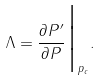Convert formula to latex. <formula><loc_0><loc_0><loc_500><loc_500>\Lambda = \frac { \partial P ^ { \prime } } { \partial P } \Big | _ { p _ { c } } .</formula> 